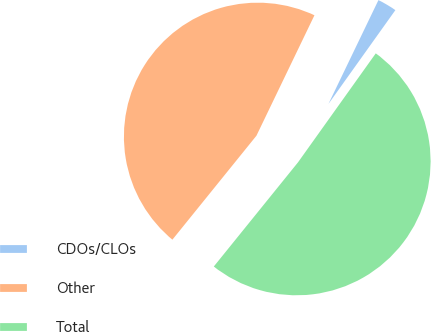Convert chart to OTSL. <chart><loc_0><loc_0><loc_500><loc_500><pie_chart><fcel>CDOs/CLOs<fcel>Other<fcel>Total<nl><fcel>2.72%<fcel>46.32%<fcel>50.95%<nl></chart> 